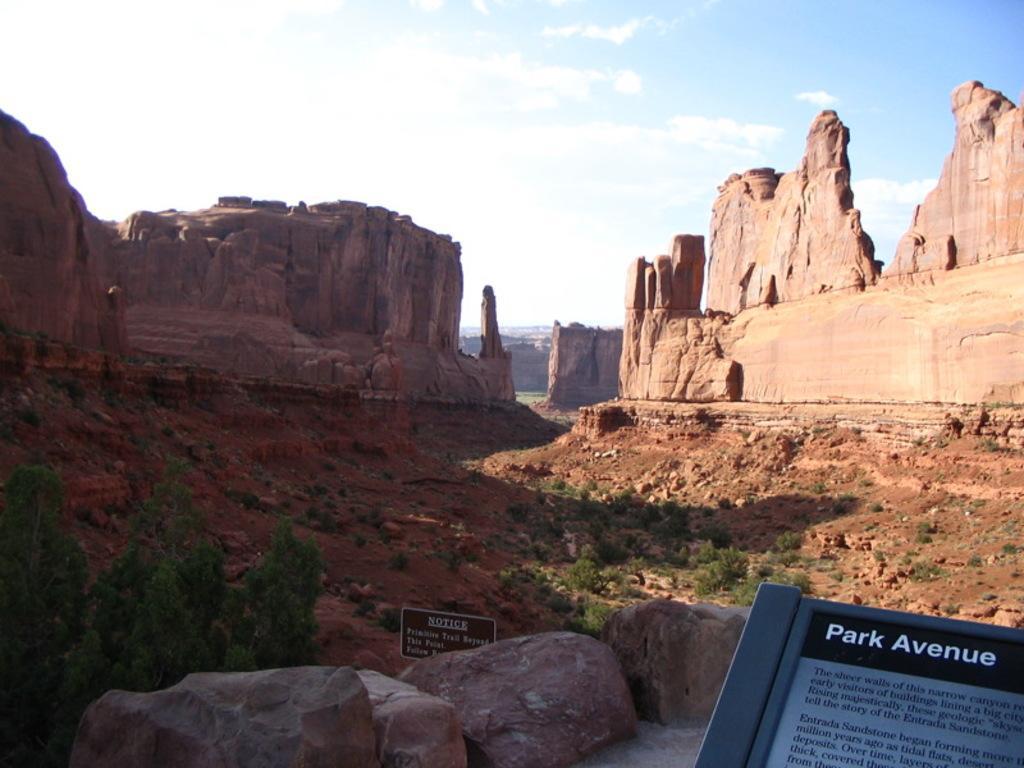Describe this image in one or two sentences. In this image there are few rock mountains, few plants and trees, stones, mud, sign boards and some clouds in the sky. 